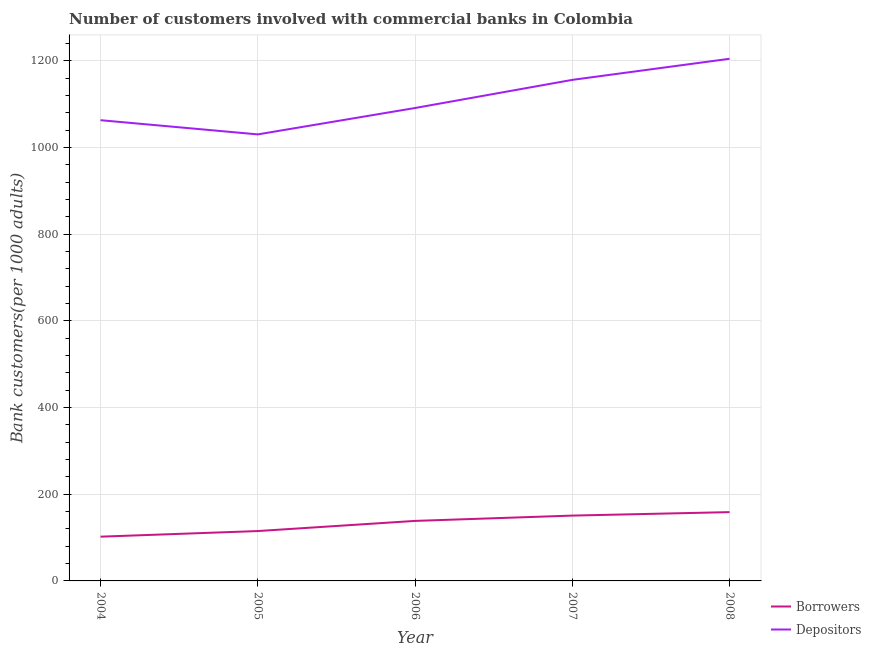How many different coloured lines are there?
Offer a very short reply. 2. Does the line corresponding to number of depositors intersect with the line corresponding to number of borrowers?
Your answer should be very brief. No. What is the number of borrowers in 2007?
Keep it short and to the point. 150.77. Across all years, what is the maximum number of borrowers?
Your response must be concise. 158.77. Across all years, what is the minimum number of borrowers?
Offer a very short reply. 102.14. In which year was the number of borrowers minimum?
Keep it short and to the point. 2004. What is the total number of depositors in the graph?
Your response must be concise. 5547.01. What is the difference between the number of borrowers in 2004 and that in 2006?
Offer a very short reply. -36.39. What is the difference between the number of depositors in 2006 and the number of borrowers in 2008?
Offer a terse response. 932.72. What is the average number of borrowers per year?
Keep it short and to the point. 133.06. In the year 2005, what is the difference between the number of borrowers and number of depositors?
Give a very brief answer. -915.5. In how many years, is the number of depositors greater than 640?
Your answer should be compact. 5. What is the ratio of the number of borrowers in 2004 to that in 2008?
Offer a very short reply. 0.64. Is the number of borrowers in 2006 less than that in 2007?
Your answer should be very brief. Yes. What is the difference between the highest and the second highest number of depositors?
Your answer should be compact. 48.7. What is the difference between the highest and the lowest number of depositors?
Offer a very short reply. 174.54. Does the number of depositors monotonically increase over the years?
Keep it short and to the point. No. Is the number of borrowers strictly less than the number of depositors over the years?
Ensure brevity in your answer.  Yes. What is the difference between two consecutive major ticks on the Y-axis?
Provide a short and direct response. 200. Are the values on the major ticks of Y-axis written in scientific E-notation?
Make the answer very short. No. Does the graph contain any zero values?
Offer a very short reply. No. Does the graph contain grids?
Ensure brevity in your answer.  Yes. How are the legend labels stacked?
Provide a short and direct response. Vertical. What is the title of the graph?
Give a very brief answer. Number of customers involved with commercial banks in Colombia. What is the label or title of the Y-axis?
Your response must be concise. Bank customers(per 1000 adults). What is the Bank customers(per 1000 adults) in Borrowers in 2004?
Offer a terse response. 102.14. What is the Bank customers(per 1000 adults) of Depositors in 2004?
Offer a very short reply. 1063.36. What is the Bank customers(per 1000 adults) in Borrowers in 2005?
Your response must be concise. 115.09. What is the Bank customers(per 1000 adults) in Depositors in 2005?
Offer a terse response. 1030.59. What is the Bank customers(per 1000 adults) in Borrowers in 2006?
Offer a very short reply. 138.53. What is the Bank customers(per 1000 adults) of Depositors in 2006?
Give a very brief answer. 1091.5. What is the Bank customers(per 1000 adults) of Borrowers in 2007?
Provide a short and direct response. 150.77. What is the Bank customers(per 1000 adults) of Depositors in 2007?
Give a very brief answer. 1156.43. What is the Bank customers(per 1000 adults) of Borrowers in 2008?
Ensure brevity in your answer.  158.77. What is the Bank customers(per 1000 adults) of Depositors in 2008?
Your answer should be compact. 1205.13. Across all years, what is the maximum Bank customers(per 1000 adults) of Borrowers?
Make the answer very short. 158.77. Across all years, what is the maximum Bank customers(per 1000 adults) of Depositors?
Keep it short and to the point. 1205.13. Across all years, what is the minimum Bank customers(per 1000 adults) in Borrowers?
Offer a terse response. 102.14. Across all years, what is the minimum Bank customers(per 1000 adults) in Depositors?
Your answer should be compact. 1030.59. What is the total Bank customers(per 1000 adults) in Borrowers in the graph?
Provide a short and direct response. 665.29. What is the total Bank customers(per 1000 adults) in Depositors in the graph?
Provide a short and direct response. 5547.01. What is the difference between the Bank customers(per 1000 adults) in Borrowers in 2004 and that in 2005?
Your answer should be very brief. -12.96. What is the difference between the Bank customers(per 1000 adults) in Depositors in 2004 and that in 2005?
Your answer should be very brief. 32.77. What is the difference between the Bank customers(per 1000 adults) of Borrowers in 2004 and that in 2006?
Your answer should be compact. -36.39. What is the difference between the Bank customers(per 1000 adults) in Depositors in 2004 and that in 2006?
Provide a short and direct response. -28.13. What is the difference between the Bank customers(per 1000 adults) in Borrowers in 2004 and that in 2007?
Your answer should be compact. -48.63. What is the difference between the Bank customers(per 1000 adults) in Depositors in 2004 and that in 2007?
Keep it short and to the point. -93.07. What is the difference between the Bank customers(per 1000 adults) in Borrowers in 2004 and that in 2008?
Keep it short and to the point. -56.63. What is the difference between the Bank customers(per 1000 adults) of Depositors in 2004 and that in 2008?
Your response must be concise. -141.77. What is the difference between the Bank customers(per 1000 adults) of Borrowers in 2005 and that in 2006?
Your response must be concise. -23.43. What is the difference between the Bank customers(per 1000 adults) of Depositors in 2005 and that in 2006?
Provide a short and direct response. -60.9. What is the difference between the Bank customers(per 1000 adults) in Borrowers in 2005 and that in 2007?
Keep it short and to the point. -35.67. What is the difference between the Bank customers(per 1000 adults) of Depositors in 2005 and that in 2007?
Your response must be concise. -125.84. What is the difference between the Bank customers(per 1000 adults) in Borrowers in 2005 and that in 2008?
Your answer should be compact. -43.68. What is the difference between the Bank customers(per 1000 adults) in Depositors in 2005 and that in 2008?
Offer a terse response. -174.54. What is the difference between the Bank customers(per 1000 adults) of Borrowers in 2006 and that in 2007?
Your answer should be very brief. -12.24. What is the difference between the Bank customers(per 1000 adults) of Depositors in 2006 and that in 2007?
Your response must be concise. -64.94. What is the difference between the Bank customers(per 1000 adults) of Borrowers in 2006 and that in 2008?
Your answer should be very brief. -20.25. What is the difference between the Bank customers(per 1000 adults) of Depositors in 2006 and that in 2008?
Keep it short and to the point. -113.64. What is the difference between the Bank customers(per 1000 adults) of Borrowers in 2007 and that in 2008?
Ensure brevity in your answer.  -8. What is the difference between the Bank customers(per 1000 adults) of Depositors in 2007 and that in 2008?
Offer a terse response. -48.7. What is the difference between the Bank customers(per 1000 adults) of Borrowers in 2004 and the Bank customers(per 1000 adults) of Depositors in 2005?
Provide a short and direct response. -928.46. What is the difference between the Bank customers(per 1000 adults) of Borrowers in 2004 and the Bank customers(per 1000 adults) of Depositors in 2006?
Make the answer very short. -989.36. What is the difference between the Bank customers(per 1000 adults) in Borrowers in 2004 and the Bank customers(per 1000 adults) in Depositors in 2007?
Your answer should be compact. -1054.3. What is the difference between the Bank customers(per 1000 adults) in Borrowers in 2004 and the Bank customers(per 1000 adults) in Depositors in 2008?
Offer a very short reply. -1103. What is the difference between the Bank customers(per 1000 adults) of Borrowers in 2005 and the Bank customers(per 1000 adults) of Depositors in 2006?
Ensure brevity in your answer.  -976.4. What is the difference between the Bank customers(per 1000 adults) of Borrowers in 2005 and the Bank customers(per 1000 adults) of Depositors in 2007?
Provide a succinct answer. -1041.34. What is the difference between the Bank customers(per 1000 adults) of Borrowers in 2005 and the Bank customers(per 1000 adults) of Depositors in 2008?
Your answer should be very brief. -1090.04. What is the difference between the Bank customers(per 1000 adults) in Borrowers in 2006 and the Bank customers(per 1000 adults) in Depositors in 2007?
Provide a succinct answer. -1017.91. What is the difference between the Bank customers(per 1000 adults) in Borrowers in 2006 and the Bank customers(per 1000 adults) in Depositors in 2008?
Offer a very short reply. -1066.61. What is the difference between the Bank customers(per 1000 adults) of Borrowers in 2007 and the Bank customers(per 1000 adults) of Depositors in 2008?
Offer a very short reply. -1054.37. What is the average Bank customers(per 1000 adults) of Borrowers per year?
Ensure brevity in your answer.  133.06. What is the average Bank customers(per 1000 adults) in Depositors per year?
Give a very brief answer. 1109.4. In the year 2004, what is the difference between the Bank customers(per 1000 adults) in Borrowers and Bank customers(per 1000 adults) in Depositors?
Your answer should be very brief. -961.22. In the year 2005, what is the difference between the Bank customers(per 1000 adults) of Borrowers and Bank customers(per 1000 adults) of Depositors?
Your answer should be very brief. -915.5. In the year 2006, what is the difference between the Bank customers(per 1000 adults) in Borrowers and Bank customers(per 1000 adults) in Depositors?
Your answer should be very brief. -952.97. In the year 2007, what is the difference between the Bank customers(per 1000 adults) of Borrowers and Bank customers(per 1000 adults) of Depositors?
Give a very brief answer. -1005.66. In the year 2008, what is the difference between the Bank customers(per 1000 adults) in Borrowers and Bank customers(per 1000 adults) in Depositors?
Your answer should be very brief. -1046.36. What is the ratio of the Bank customers(per 1000 adults) in Borrowers in 2004 to that in 2005?
Make the answer very short. 0.89. What is the ratio of the Bank customers(per 1000 adults) of Depositors in 2004 to that in 2005?
Keep it short and to the point. 1.03. What is the ratio of the Bank customers(per 1000 adults) in Borrowers in 2004 to that in 2006?
Offer a very short reply. 0.74. What is the ratio of the Bank customers(per 1000 adults) in Depositors in 2004 to that in 2006?
Offer a terse response. 0.97. What is the ratio of the Bank customers(per 1000 adults) of Borrowers in 2004 to that in 2007?
Your answer should be compact. 0.68. What is the ratio of the Bank customers(per 1000 adults) in Depositors in 2004 to that in 2007?
Offer a terse response. 0.92. What is the ratio of the Bank customers(per 1000 adults) in Borrowers in 2004 to that in 2008?
Provide a short and direct response. 0.64. What is the ratio of the Bank customers(per 1000 adults) in Depositors in 2004 to that in 2008?
Provide a short and direct response. 0.88. What is the ratio of the Bank customers(per 1000 adults) in Borrowers in 2005 to that in 2006?
Provide a short and direct response. 0.83. What is the ratio of the Bank customers(per 1000 adults) in Depositors in 2005 to that in 2006?
Keep it short and to the point. 0.94. What is the ratio of the Bank customers(per 1000 adults) of Borrowers in 2005 to that in 2007?
Give a very brief answer. 0.76. What is the ratio of the Bank customers(per 1000 adults) in Depositors in 2005 to that in 2007?
Your answer should be compact. 0.89. What is the ratio of the Bank customers(per 1000 adults) of Borrowers in 2005 to that in 2008?
Your answer should be compact. 0.72. What is the ratio of the Bank customers(per 1000 adults) of Depositors in 2005 to that in 2008?
Provide a succinct answer. 0.86. What is the ratio of the Bank customers(per 1000 adults) in Borrowers in 2006 to that in 2007?
Your response must be concise. 0.92. What is the ratio of the Bank customers(per 1000 adults) of Depositors in 2006 to that in 2007?
Keep it short and to the point. 0.94. What is the ratio of the Bank customers(per 1000 adults) of Borrowers in 2006 to that in 2008?
Offer a very short reply. 0.87. What is the ratio of the Bank customers(per 1000 adults) in Depositors in 2006 to that in 2008?
Offer a very short reply. 0.91. What is the ratio of the Bank customers(per 1000 adults) of Borrowers in 2007 to that in 2008?
Your answer should be very brief. 0.95. What is the ratio of the Bank customers(per 1000 adults) of Depositors in 2007 to that in 2008?
Your answer should be very brief. 0.96. What is the difference between the highest and the second highest Bank customers(per 1000 adults) of Borrowers?
Provide a short and direct response. 8. What is the difference between the highest and the second highest Bank customers(per 1000 adults) in Depositors?
Offer a terse response. 48.7. What is the difference between the highest and the lowest Bank customers(per 1000 adults) in Borrowers?
Provide a succinct answer. 56.63. What is the difference between the highest and the lowest Bank customers(per 1000 adults) in Depositors?
Give a very brief answer. 174.54. 